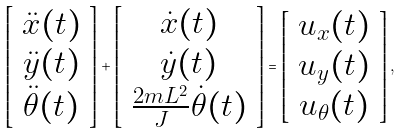Convert formula to latex. <formula><loc_0><loc_0><loc_500><loc_500>\left [ \begin{array} { c } \ddot { x } ( t ) \\ \ddot { y } ( t ) \\ \ddot { \theta } ( t ) \end{array} \right ] + \left [ \begin{array} { c } \dot { x } ( t ) \\ \dot { y } ( t ) \\ \frac { 2 m L ^ { 2 } } { J } \dot { \theta } ( t ) \end{array} \right ] = \left [ \begin{array} { c } u _ { x } ( t ) \\ u _ { y } ( t ) \\ u _ { \theta } ( t ) \end{array} \right ] ,</formula> 